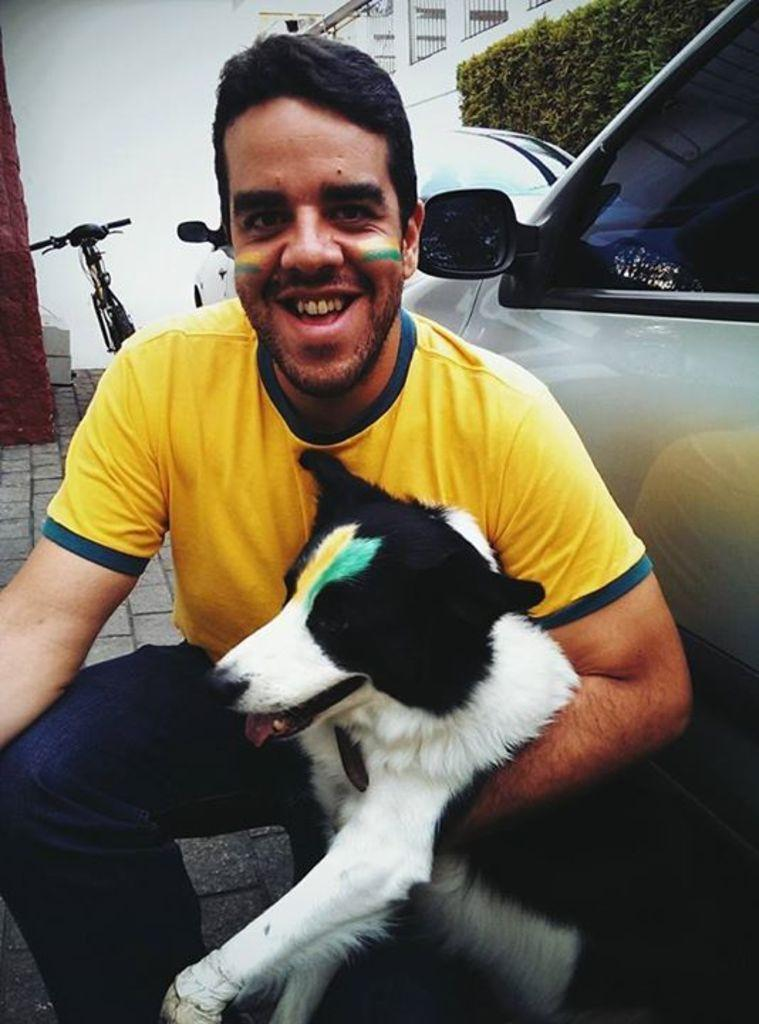What is the man in the image doing? The man is sitting on his knees and holding a dog in his hands. What is the man's facial expression in the image? The man is smiling. What can be seen in the background of the image? There is a bicycle, a wall, trees, and a fence in the background of the image. What type of toothbrush is the man using to brush the dog's teeth in the image? There is no toothbrush present in the image, and the man is not brushing the dog's teeth. 